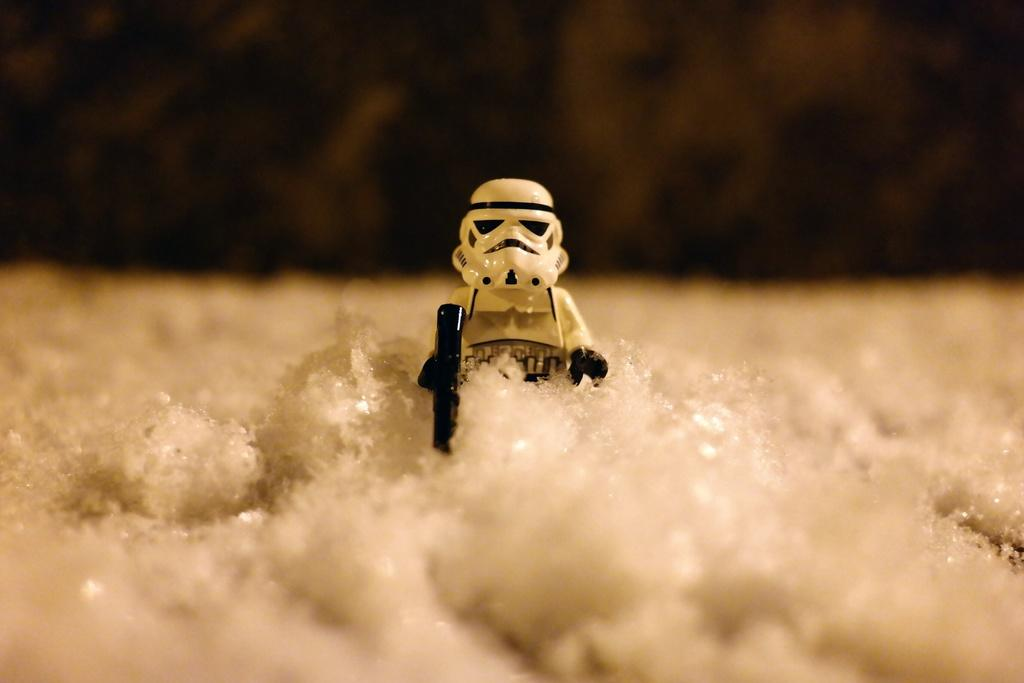What is the main subject in the center of the image? There is a white-colored toy in the center of the image. What else can be seen in the front of the image? There are white-colored things in the front of the image. How would you describe the background of the image? The background of the image is blurry. What type of crack is visible in the image? There is no crack present in the image. 